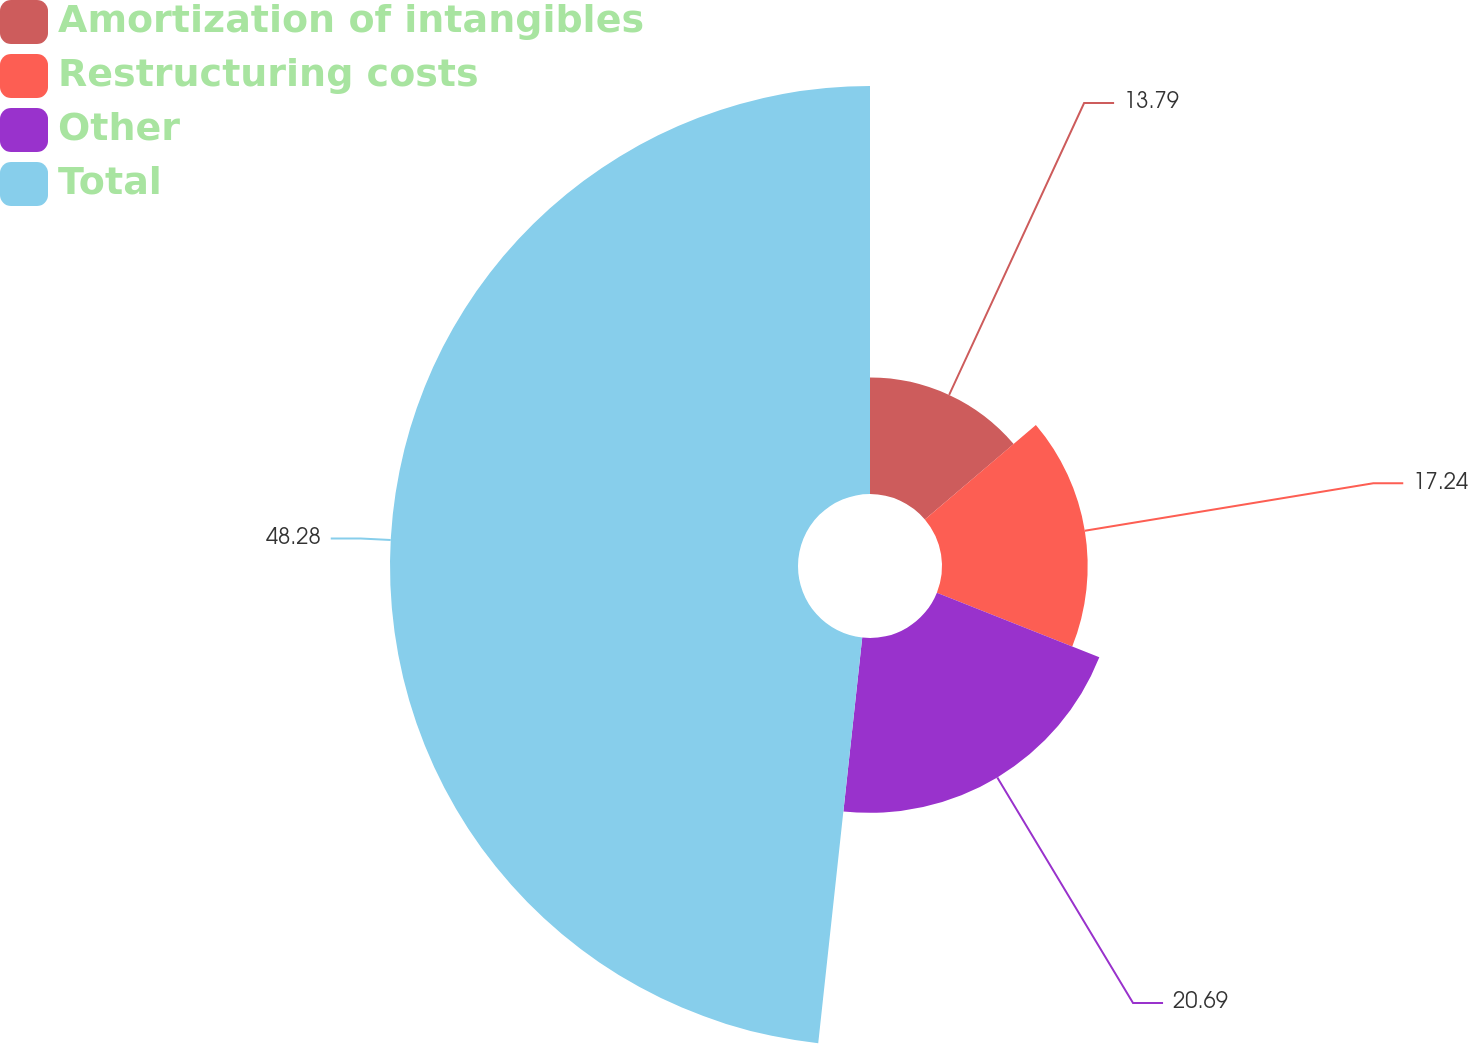Convert chart. <chart><loc_0><loc_0><loc_500><loc_500><pie_chart><fcel>Amortization of intangibles<fcel>Restructuring costs<fcel>Other<fcel>Total<nl><fcel>13.79%<fcel>17.24%<fcel>20.69%<fcel>48.28%<nl></chart> 